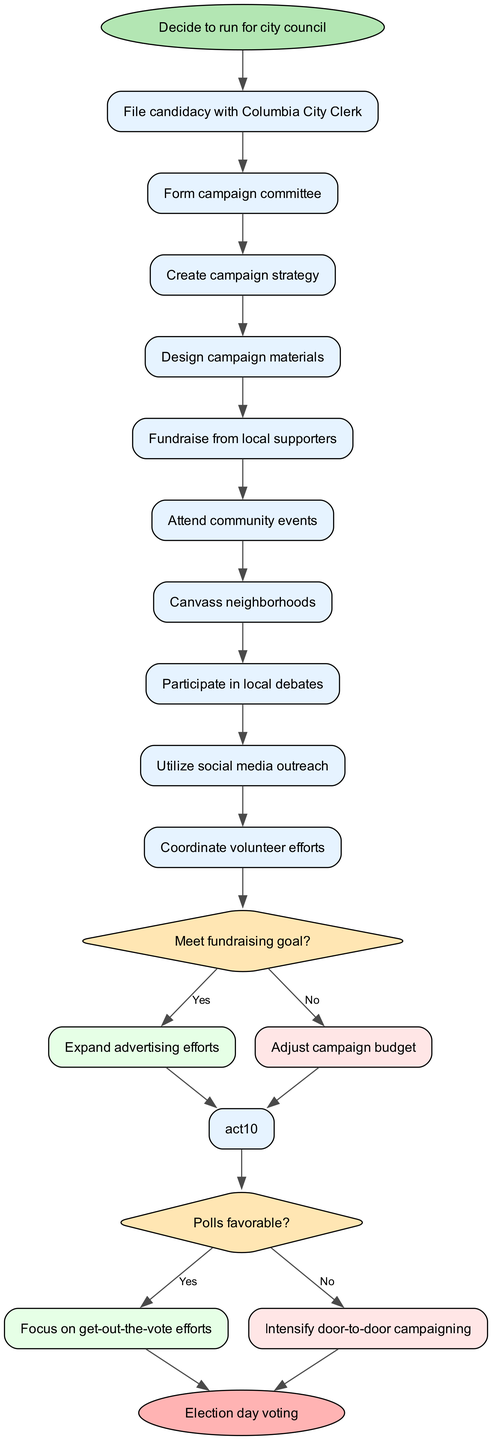What is the start node of the campaign process? The start node is specified as "Decide to run for city council," which indicates the beginning of the workflow in the diagram.
Answer: Decide to run for city council How many activities are listed in the diagram? There are 10 activities listed in the diagram, as shown in the activities section.
Answer: 10 What is the first decision point in the campaign process? The first decision point is labeled "Meet fundraising goal?" and is the first diamond shape seen in the diagram after completing the last activity before the decision.
Answer: Meet fundraising goal? What action follows a "No" answer to the fundraising goal decision? A "No" answer leads to "Adjust campaign budget," indicating a budget modification is necessary if the fundraising goal is not met.
Answer: Adjust campaign budget What happens after answering "Yes" to the polls being favorable? Answering "Yes" to the polls being favorable results in "Focus on get-out-the-vote efforts," directing the campaign's attention to boosting voter turnout.
Answer: Focus on get-out-the-vote efforts How many edges lead to the end node? There are two edges leading to the end node "Election day voting," one from each "Yes" and "No" paths of the last decision point.
Answer: 2 What is the last activity before the first decision? The last activity before the first decision is "Fundraise from local supporters," which is the 5th activity listed.
Answer: Fundraise from local supporters What does the path labeled "No" from the second decision point lead to? The "No" path from the second decision point leads directly to the end node "Election day voting," indicating that the campaign concludes regardless of the decision outcome.
Answer: Election day voting What is indicated by the diamond shapes in the diagram? The diamond shapes indicate decision points in the campaign process, where different paths are determined based on "Yes" or "No" answers to key questions.
Answer: Decision points 